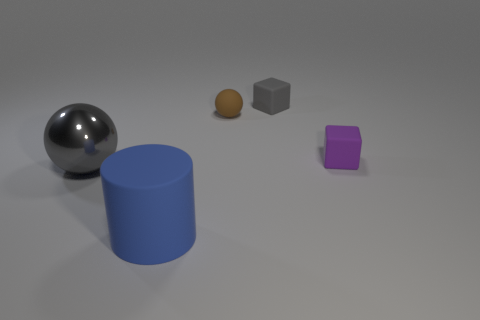Are there any cubes that have the same color as the big metal sphere?
Ensure brevity in your answer.  Yes. The gray metal thing that is the same size as the cylinder is what shape?
Provide a short and direct response. Sphere. Is the number of big metal things less than the number of large red metal spheres?
Your answer should be compact. No. How many gray metal objects have the same size as the blue matte object?
Provide a short and direct response. 1. The object that is the same color as the large shiny sphere is what shape?
Offer a terse response. Cube. What is the big cylinder made of?
Give a very brief answer. Rubber. How big is the ball on the left side of the big matte object?
Provide a succinct answer. Large. How many small brown matte things have the same shape as the shiny thing?
Your answer should be very brief. 1. What shape is the gray object that is made of the same material as the cylinder?
Your response must be concise. Cube. How many brown objects are either tiny things or large metal spheres?
Keep it short and to the point. 1. 